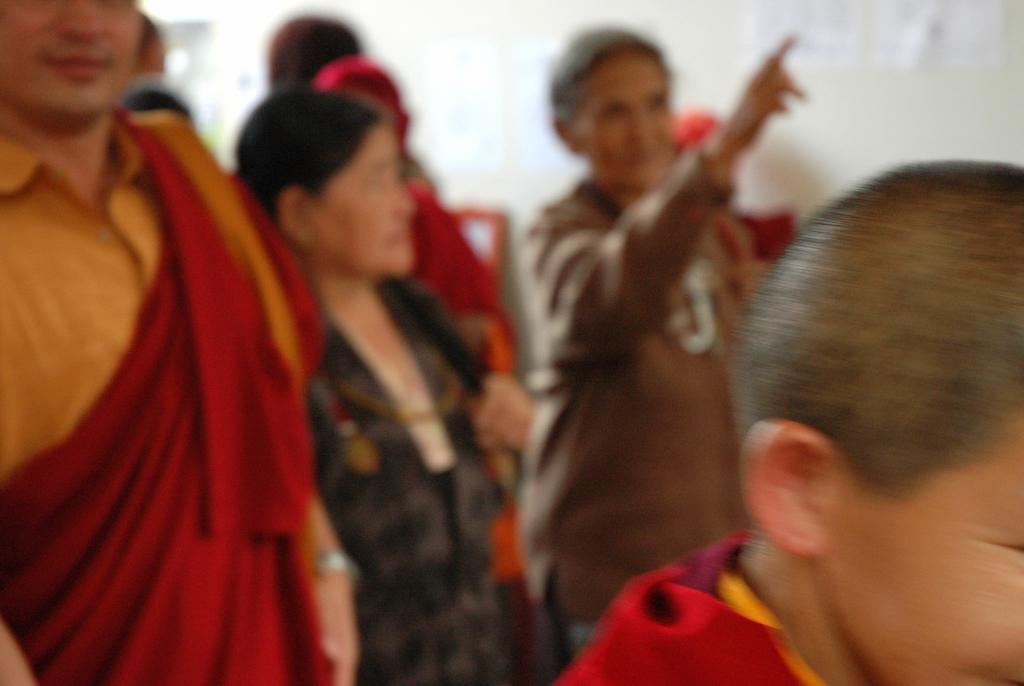In one or two sentences, can you explain what this image depicts? In this image, we can see people standing and in the background, there is wall. 